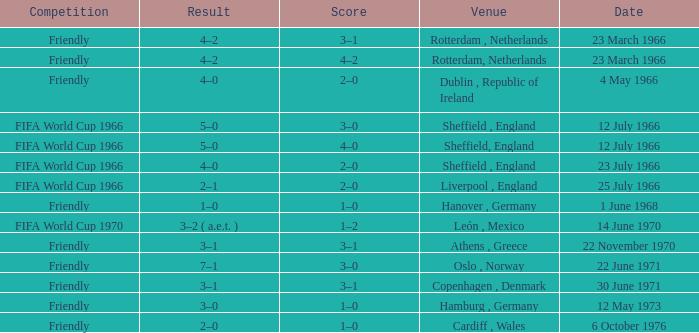Which result's venue was in Rotterdam, Netherlands? 4–2, 4–2. 